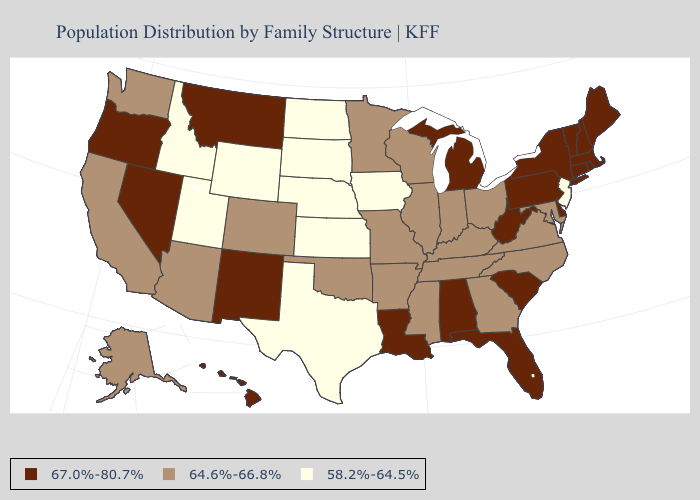Does Vermont have a higher value than Michigan?
Be succinct. No. Name the states that have a value in the range 67.0%-80.7%?
Keep it brief. Alabama, Connecticut, Delaware, Florida, Hawaii, Louisiana, Maine, Massachusetts, Michigan, Montana, Nevada, New Hampshire, New Mexico, New York, Oregon, Pennsylvania, Rhode Island, South Carolina, Vermont, West Virginia. What is the lowest value in the USA?
Write a very short answer. 58.2%-64.5%. Name the states that have a value in the range 64.6%-66.8%?
Give a very brief answer. Alaska, Arizona, Arkansas, California, Colorado, Georgia, Illinois, Indiana, Kentucky, Maryland, Minnesota, Mississippi, Missouri, North Carolina, Ohio, Oklahoma, Tennessee, Virginia, Washington, Wisconsin. Among the states that border Idaho , does Wyoming have the highest value?
Give a very brief answer. No. Name the states that have a value in the range 67.0%-80.7%?
Write a very short answer. Alabama, Connecticut, Delaware, Florida, Hawaii, Louisiana, Maine, Massachusetts, Michigan, Montana, Nevada, New Hampshire, New Mexico, New York, Oregon, Pennsylvania, Rhode Island, South Carolina, Vermont, West Virginia. Does Mississippi have a higher value than Iowa?
Quick response, please. Yes. Does Nebraska have the lowest value in the USA?
Concise answer only. Yes. What is the value of New Jersey?
Keep it brief. 58.2%-64.5%. Name the states that have a value in the range 64.6%-66.8%?
Answer briefly. Alaska, Arizona, Arkansas, California, Colorado, Georgia, Illinois, Indiana, Kentucky, Maryland, Minnesota, Mississippi, Missouri, North Carolina, Ohio, Oklahoma, Tennessee, Virginia, Washington, Wisconsin. What is the value of Illinois?
Give a very brief answer. 64.6%-66.8%. Name the states that have a value in the range 64.6%-66.8%?
Short answer required. Alaska, Arizona, Arkansas, California, Colorado, Georgia, Illinois, Indiana, Kentucky, Maryland, Minnesota, Mississippi, Missouri, North Carolina, Ohio, Oklahoma, Tennessee, Virginia, Washington, Wisconsin. Does Idaho have a higher value than Alabama?
Be succinct. No. Among the states that border Maryland , does Virginia have the highest value?
Answer briefly. No. What is the highest value in the USA?
Short answer required. 67.0%-80.7%. 